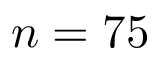Convert formula to latex. <formula><loc_0><loc_0><loc_500><loc_500>n = 7 5</formula> 